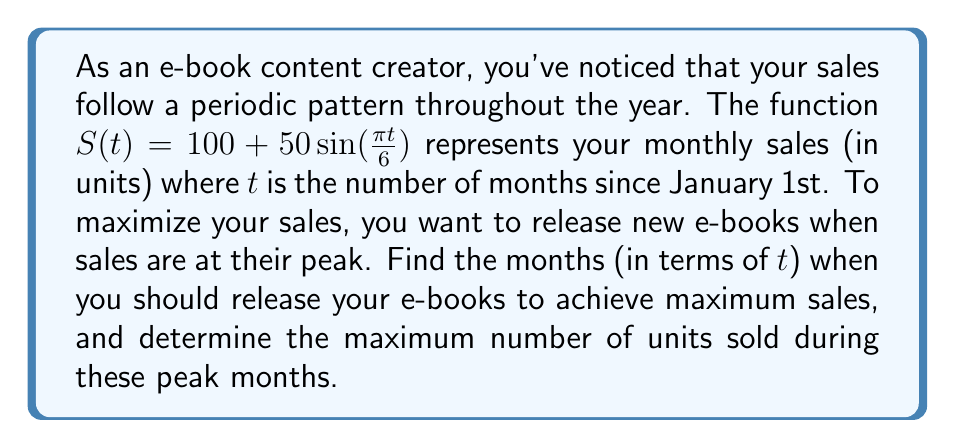Can you solve this math problem? 1) To find the peak sales, we need to determine the maximum value of the function $S(t) = 100 + 50\sin(\frac{\pi t}{6})$.

2) The sine function reaches its maximum value of 1 when its argument is $\frac{\pi}{2} + 2\pi n$, where $n$ is any integer.

3) So, we set up the equation:
   $$\frac{\pi t}{6} = \frac{\pi}{2} + 2\pi n$$

4) Solve for $t$:
   $$t = 3 + 12n$$

5) This means the sales peak every 12 months (which makes sense for an annual cycle), starting at $t = 3$ (March).

6) To find the maximum number of units sold, we substitute the maximum value of sine (1) into the original function:
   $$S_{max} = 100 + 50(1) = 150$$

Therefore, you should release your e-books every March (t = 3) and every 12 months thereafter (t = 15, 27, etc.), and you can expect to sell a maximum of 150 units during these peak months.
Answer: Release months: $t = 3 + 12n$, where $n$ is any non-negative integer. Maximum sales: 150 units. 